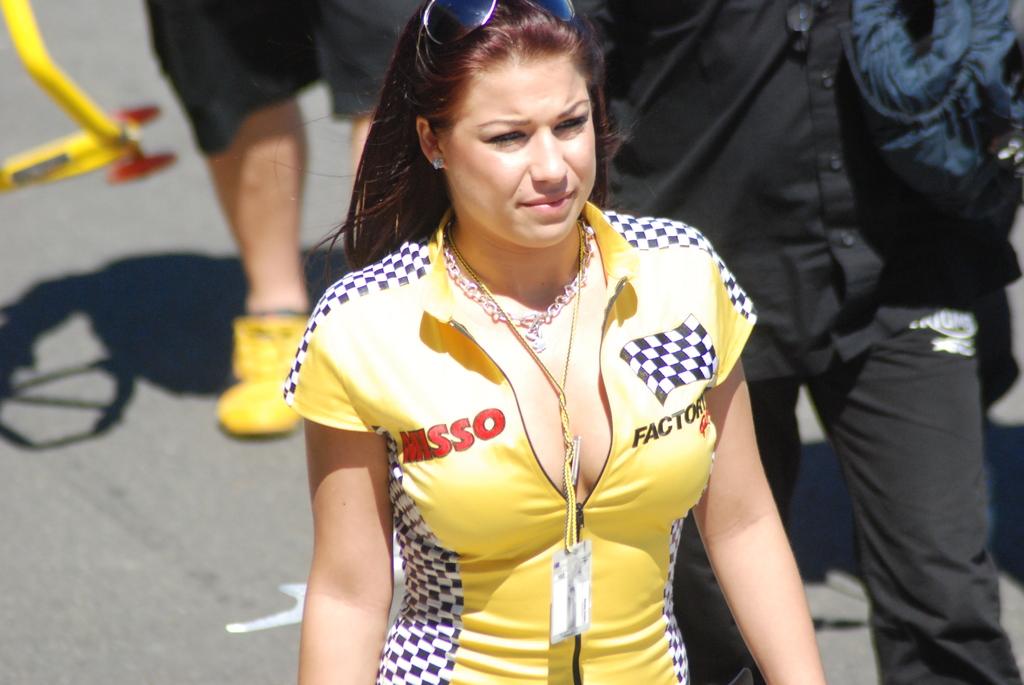What is one of the words on her uniform?
Give a very brief answer. Misso. What does it say in red on her uniform?
Offer a very short reply. Misso. 